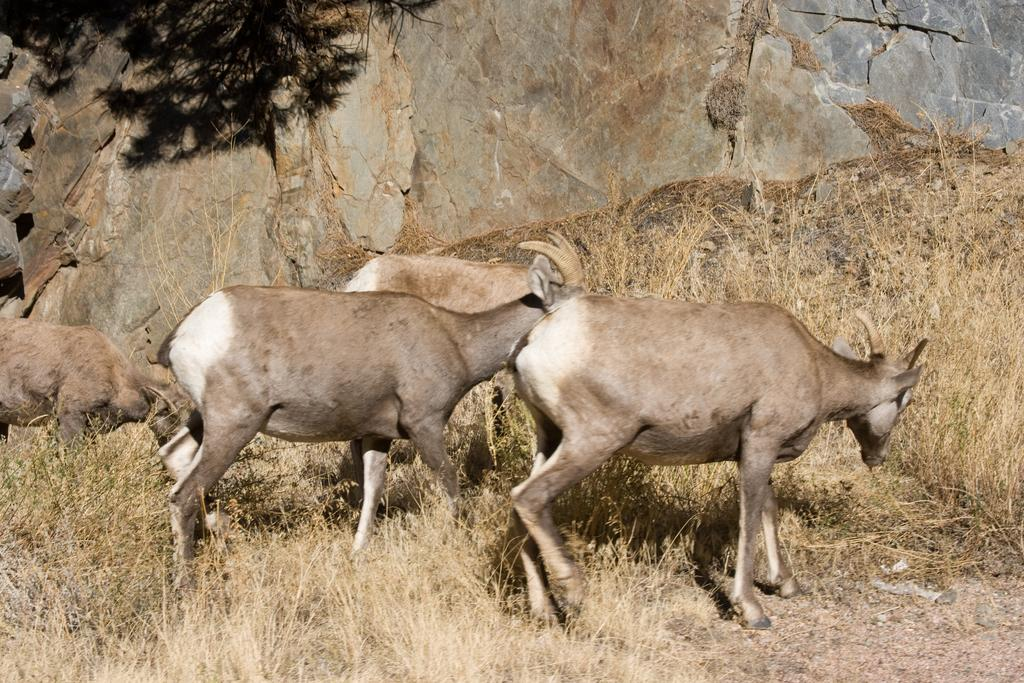What animals are present on the ground in the image? There are goats on the ground in the image. What type of vegetation can be seen in the image? There is grass visible in the image. What type of natural elements are present in the image? There are stones and a rock in the image. What type of cloth is being used by the rat in the image? There is no rat present in the image, and therefore no cloth being used by a rat. 